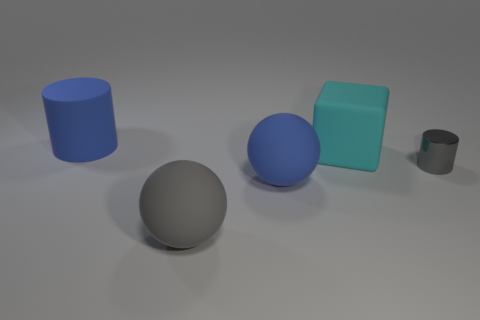Add 5 rubber cubes. How many objects exist? 10 Subtract 1 cyan blocks. How many objects are left? 4 Subtract all spheres. How many objects are left? 3 Subtract all blue cylinders. Subtract all gray cubes. How many cylinders are left? 1 Subtract all big spheres. Subtract all shiny objects. How many objects are left? 2 Add 1 blue things. How many blue things are left? 3 Add 2 big gray matte things. How many big gray matte things exist? 3 